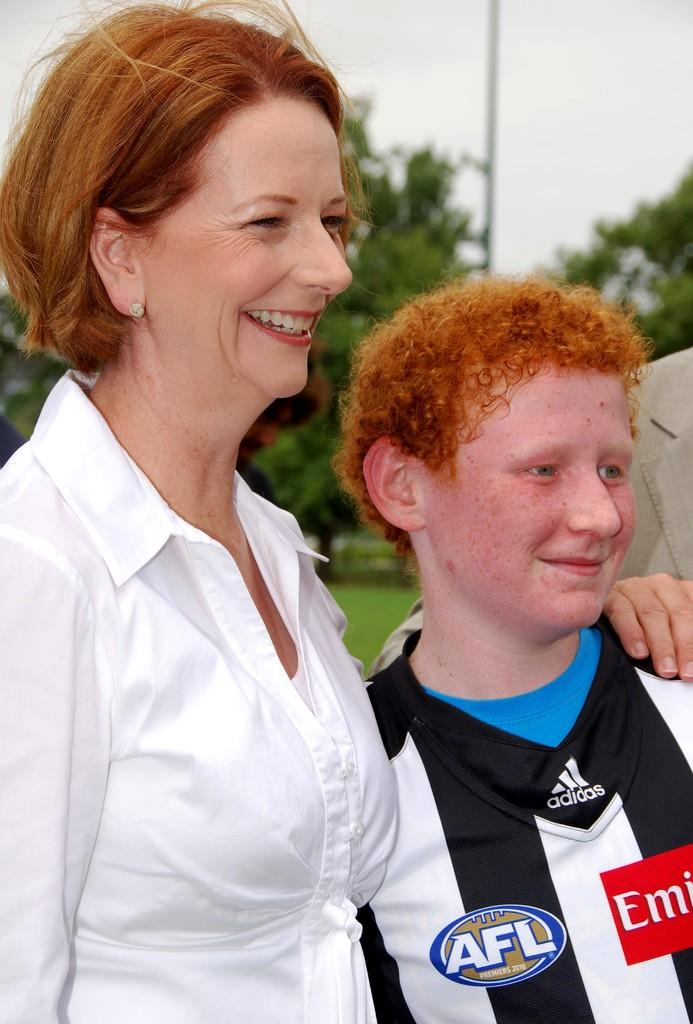<image>
Relay a brief, clear account of the picture shown. A woman stands next to a red-headed boy who is wearing an Adidas shirt. 